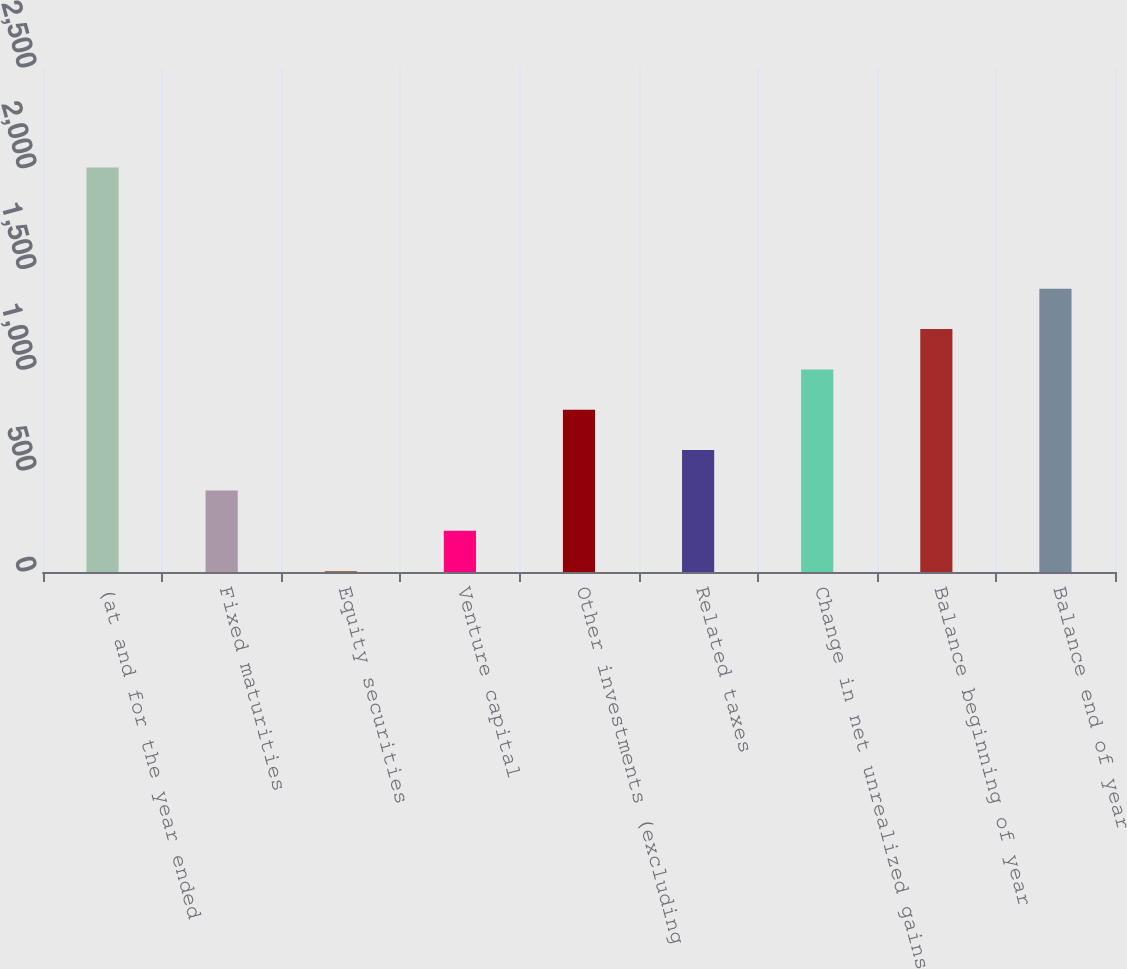Convert chart. <chart><loc_0><loc_0><loc_500><loc_500><bar_chart><fcel>(at and for the year ended<fcel>Fixed maturities<fcel>Equity securities<fcel>Venture capital<fcel>Other investments (excluding<fcel>Related taxes<fcel>Change in net unrealized gains<fcel>Balance beginning of year<fcel>Balance end of year<nl><fcel>2006<fcel>404.4<fcel>4<fcel>204.2<fcel>804.8<fcel>604.6<fcel>1005<fcel>1205.2<fcel>1405.4<nl></chart> 